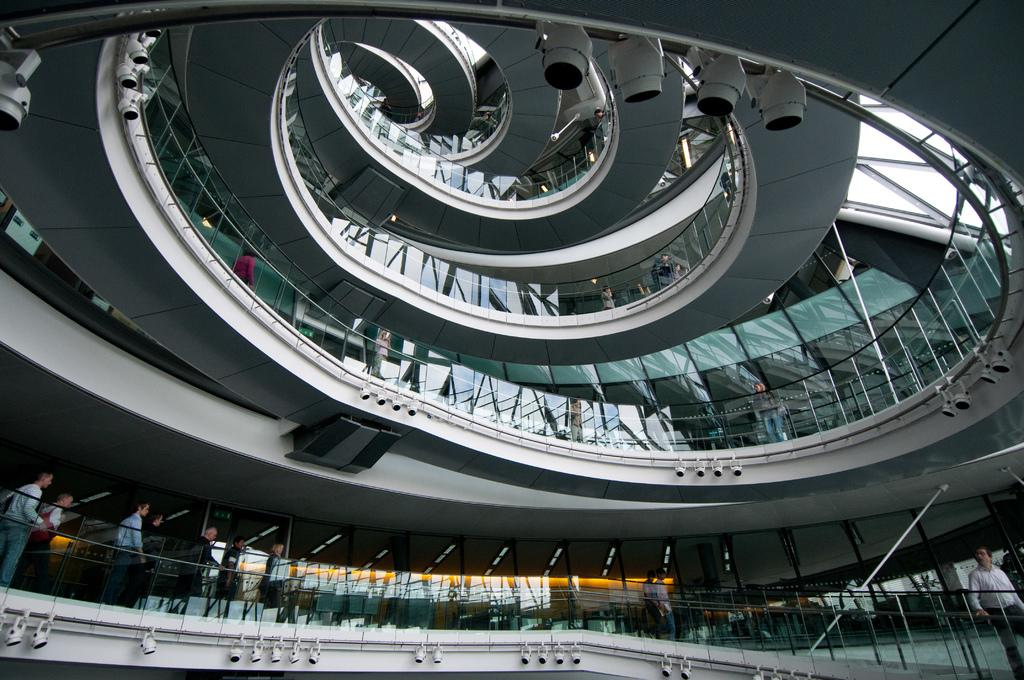What type of location is depicted in the image? The image is an inside view of a building. Are there any people present in the image? Yes, there are people in the image. What type of lighting can be seen in the image? There are focus lights in the image. What type of architectural feature is present in the image? There are glass doors in the image. What type of shoes is the father wearing in the image? There is no father present in the image, and therefore no shoes to describe. 